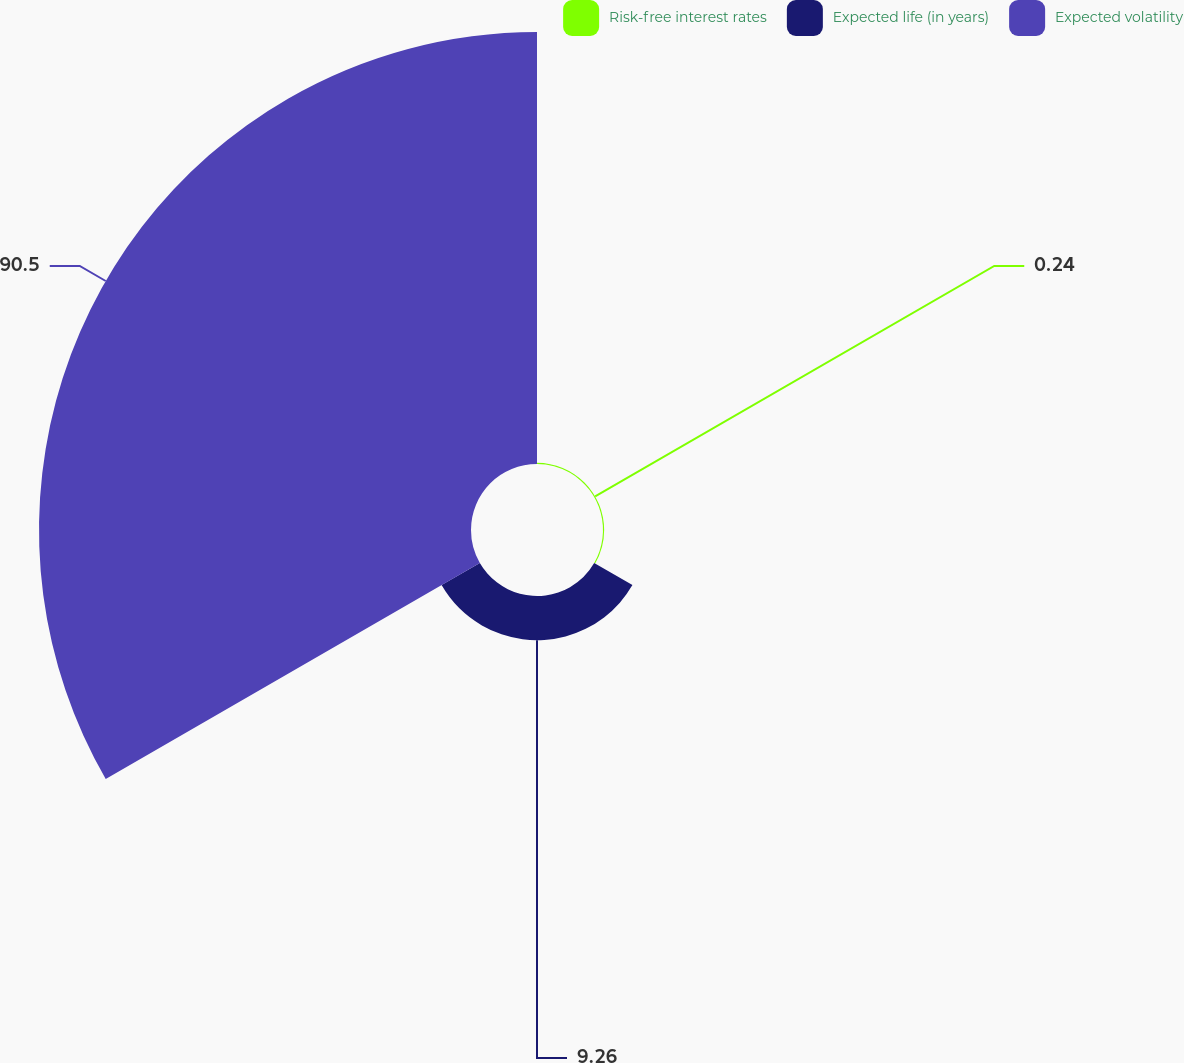Convert chart to OTSL. <chart><loc_0><loc_0><loc_500><loc_500><pie_chart><fcel>Risk-free interest rates<fcel>Expected life (in years)<fcel>Expected volatility<nl><fcel>0.24%<fcel>9.26%<fcel>90.5%<nl></chart> 